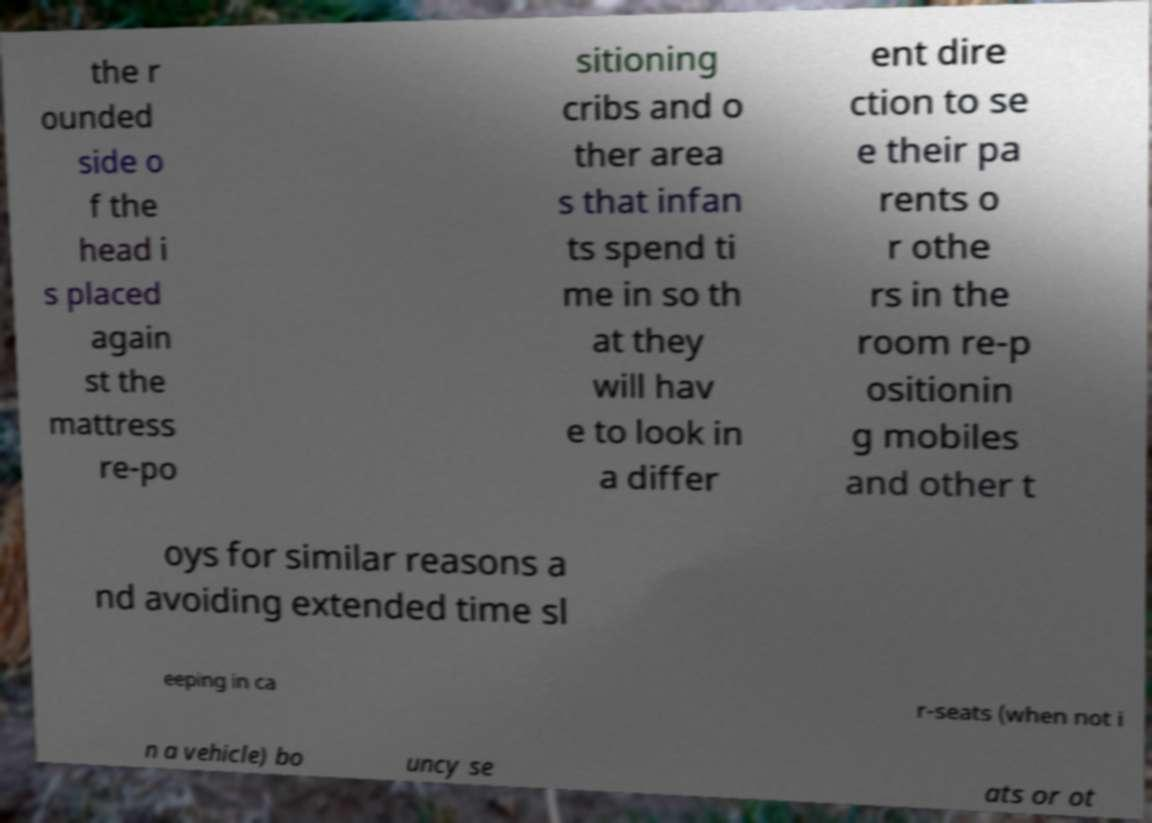What messages or text are displayed in this image? I need them in a readable, typed format. the r ounded side o f the head i s placed again st the mattress re-po sitioning cribs and o ther area s that infan ts spend ti me in so th at they will hav e to look in a differ ent dire ction to se e their pa rents o r othe rs in the room re-p ositionin g mobiles and other t oys for similar reasons a nd avoiding extended time sl eeping in ca r-seats (when not i n a vehicle) bo uncy se ats or ot 